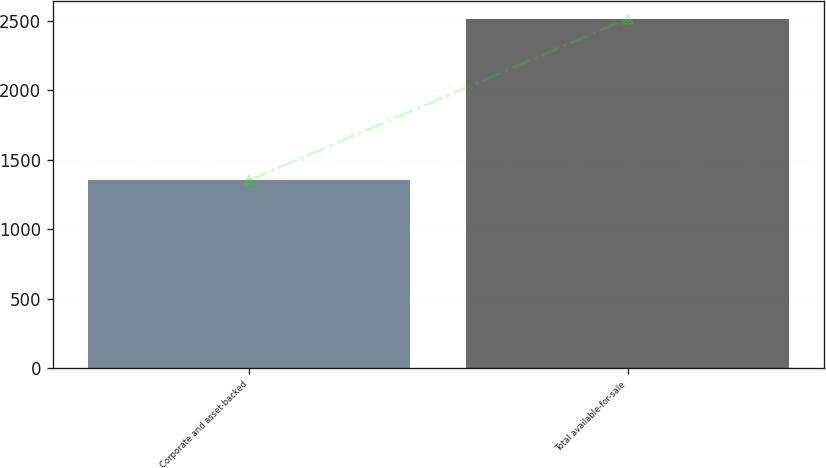<chart> <loc_0><loc_0><loc_500><loc_500><bar_chart><fcel>Corporate and asset-backed<fcel>Total available-for-sale<nl><fcel>1350<fcel>2514<nl></chart> 